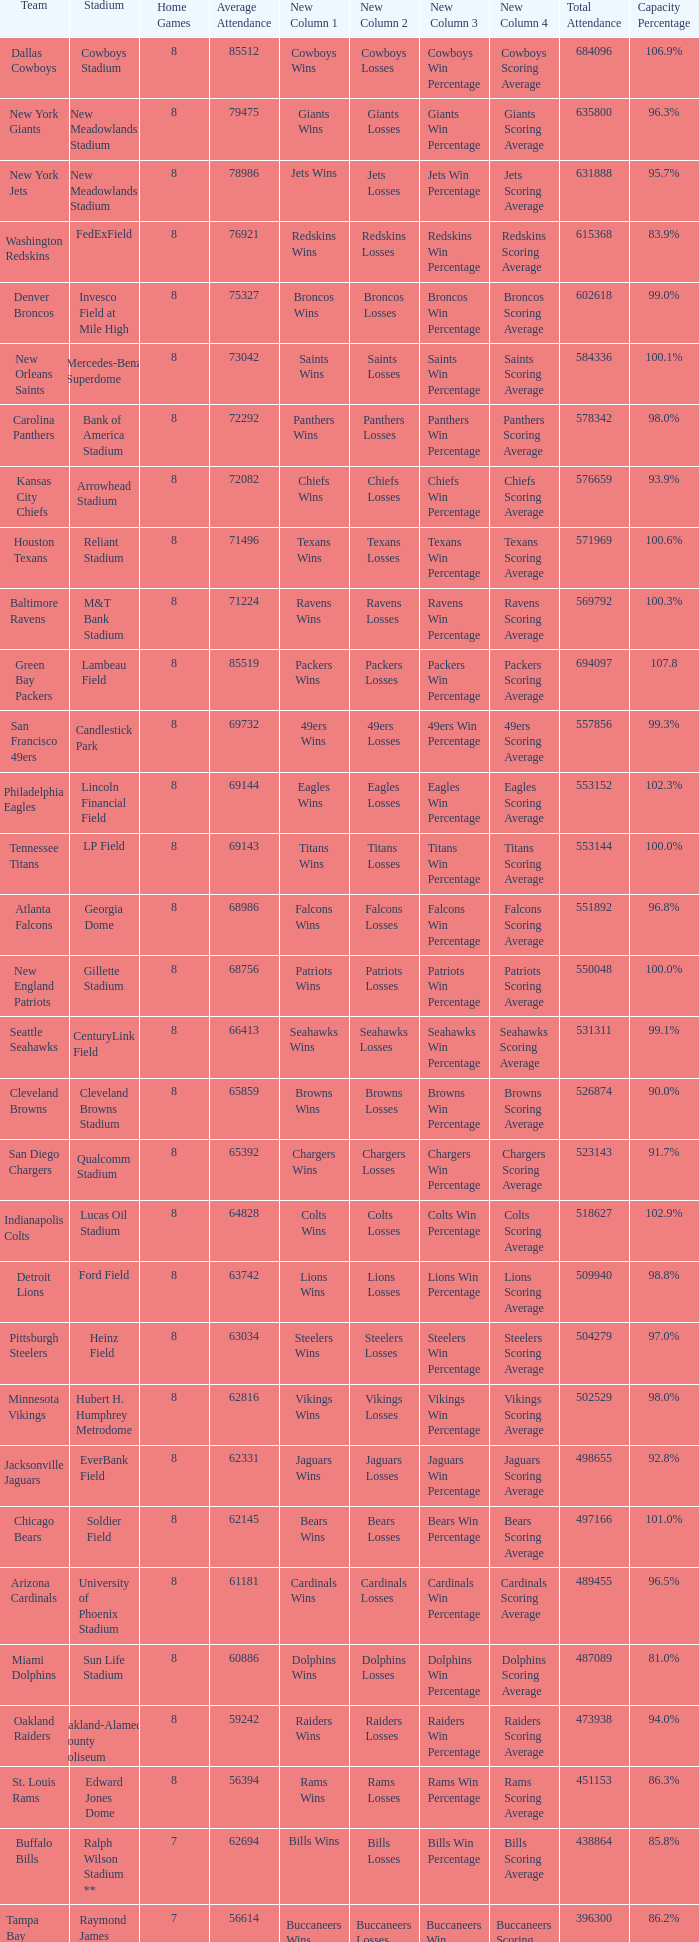What is the name of the stadium when the capacity percentage is 83.9% FedExField. 